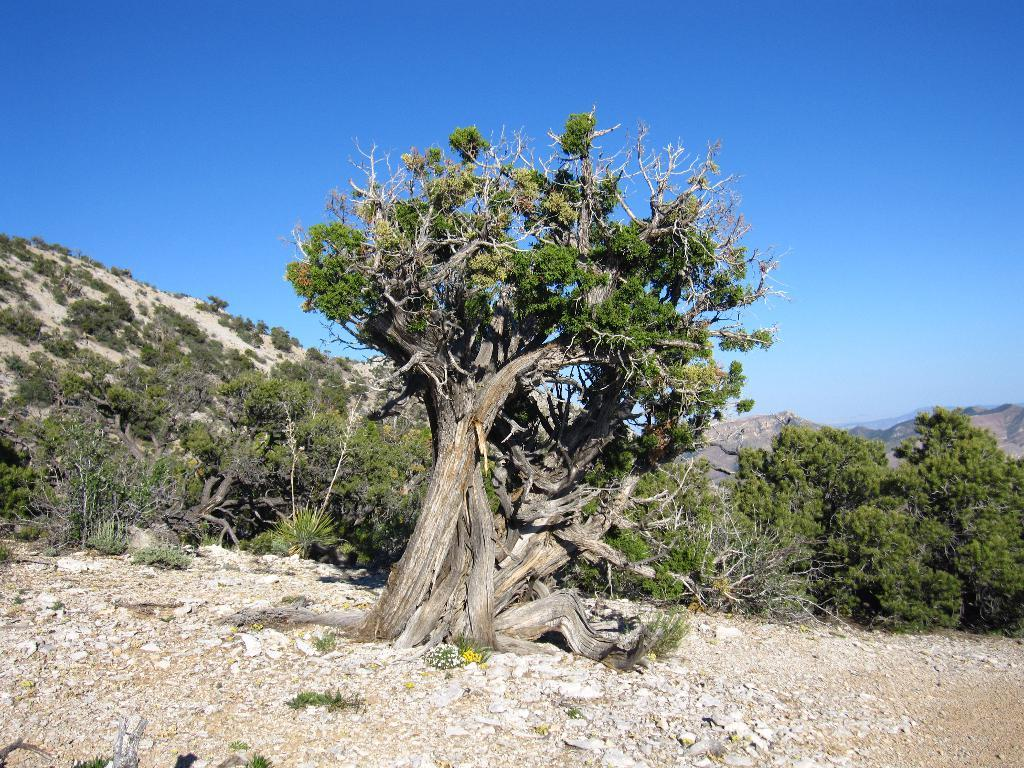What type of vegetation is present on the ground in the image? There are trees on the ground in the image. What type of natural formation can be seen in the distance? There are mountains visible in the background of the image. What part of the natural environment is visible in the background of the image? The sky is visible in the background of the image. What shape is the goose in the image? There is no goose present in the image. What type of weather can be observed in the image? The provided facts do not mention any specific weather conditions, so it cannot be determined from the image. 